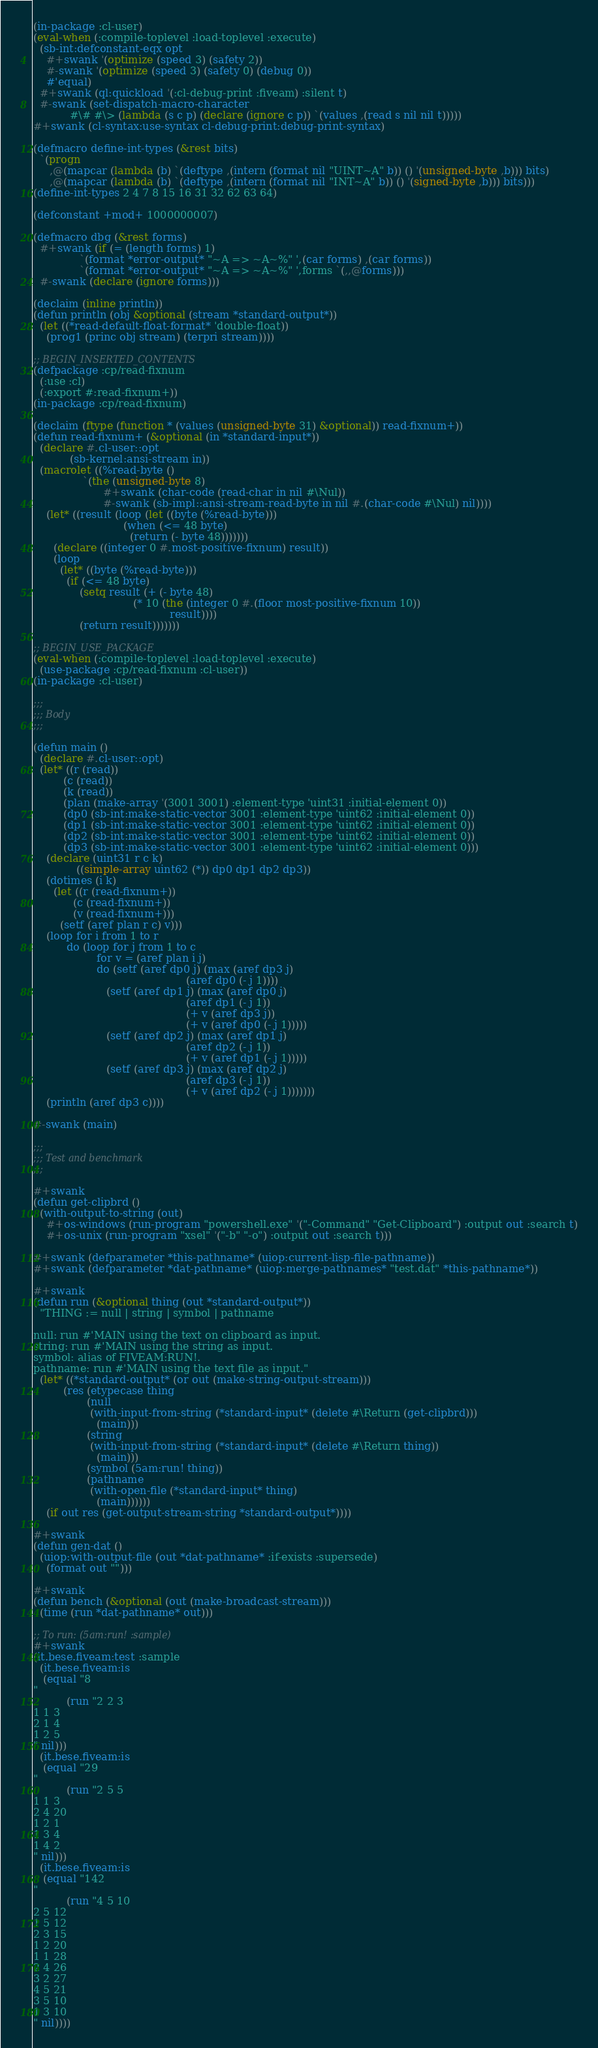<code> <loc_0><loc_0><loc_500><loc_500><_Lisp_>(in-package :cl-user)
(eval-when (:compile-toplevel :load-toplevel :execute)
  (sb-int:defconstant-eqx opt
    #+swank '(optimize (speed 3) (safety 2))
    #-swank '(optimize (speed 3) (safety 0) (debug 0))
    #'equal)
  #+swank (ql:quickload '(:cl-debug-print :fiveam) :silent t)
  #-swank (set-dispatch-macro-character
           #\# #\> (lambda (s c p) (declare (ignore c p)) `(values ,(read s nil nil t)))))
#+swank (cl-syntax:use-syntax cl-debug-print:debug-print-syntax)

(defmacro define-int-types (&rest bits)
  `(progn
     ,@(mapcar (lambda (b) `(deftype ,(intern (format nil "UINT~A" b)) () '(unsigned-byte ,b))) bits)
     ,@(mapcar (lambda (b) `(deftype ,(intern (format nil "INT~A" b)) () '(signed-byte ,b))) bits)))
(define-int-types 2 4 7 8 15 16 31 32 62 63 64)

(defconstant +mod+ 1000000007)

(defmacro dbg (&rest forms)
  #+swank (if (= (length forms) 1)
              `(format *error-output* "~A => ~A~%" ',(car forms) ,(car forms))
              `(format *error-output* "~A => ~A~%" ',forms `(,,@forms)))
  #-swank (declare (ignore forms)))

(declaim (inline println))
(defun println (obj &optional (stream *standard-output*))
  (let ((*read-default-float-format* 'double-float))
    (prog1 (princ obj stream) (terpri stream))))

;; BEGIN_INSERTED_CONTENTS
(defpackage :cp/read-fixnum
  (:use :cl)
  (:export #:read-fixnum+))
(in-package :cp/read-fixnum)

(declaim (ftype (function * (values (unsigned-byte 31) &optional)) read-fixnum+))
(defun read-fixnum+ (&optional (in *standard-input*))
  (declare #.cl-user::opt
           (sb-kernel:ansi-stream in))
  (macrolet ((%read-byte ()
               `(the (unsigned-byte 8)
                     #+swank (char-code (read-char in nil #\Nul))
                     #-swank (sb-impl::ansi-stream-read-byte in nil #.(char-code #\Nul) nil))))
    (let* ((result (loop (let ((byte (%read-byte)))
                           (when (<= 48 byte)
                             (return (- byte 48)))))))
      (declare ((integer 0 #.most-positive-fixnum) result))
      (loop
        (let* ((byte (%read-byte)))
          (if (<= 48 byte)
              (setq result (+ (- byte 48)
                              (* 10 (the (integer 0 #.(floor most-positive-fixnum 10))
                                         result))))
              (return result)))))))

;; BEGIN_USE_PACKAGE
(eval-when (:compile-toplevel :load-toplevel :execute)
  (use-package :cp/read-fixnum :cl-user))
(in-package :cl-user)

;;;
;;; Body
;;;

(defun main ()
  (declare #.cl-user::opt)
  (let* ((r (read))
         (c (read))
         (k (read))
         (plan (make-array '(3001 3001) :element-type 'uint31 :initial-element 0))
         (dp0 (sb-int:make-static-vector 3001 :element-type 'uint62 :initial-element 0))
         (dp1 (sb-int:make-static-vector 3001 :element-type 'uint62 :initial-element 0))
         (dp2 (sb-int:make-static-vector 3001 :element-type 'uint62 :initial-element 0))
         (dp3 (sb-int:make-static-vector 3001 :element-type 'uint62 :initial-element 0)))
    (declare (uint31 r c k)
             ((simple-array uint62 (*)) dp0 dp1 dp2 dp3))
    (dotimes (i k)
      (let ((r (read-fixnum+))
            (c (read-fixnum+))
            (v (read-fixnum+)))
        (setf (aref plan r c) v)))
    (loop for i from 1 to r
          do (loop for j from 1 to c
                   for v = (aref plan i j)
                   do (setf (aref dp0 j) (max (aref dp3 j)
                                              (aref dp0 (- j 1))))
                      (setf (aref dp1 j) (max (aref dp0 j)
                                              (aref dp1 (- j 1))
                                              (+ v (aref dp3 j))
                                              (+ v (aref dp0 (- j 1)))))
                      (setf (aref dp2 j) (max (aref dp1 j)
                                              (aref dp2 (- j 1))
                                              (+ v (aref dp1 (- j 1)))))
                      (setf (aref dp3 j) (max (aref dp2 j)
                                              (aref dp3 (- j 1))
                                              (+ v (aref dp2 (- j 1)))))))
    (println (aref dp3 c))))

#-swank (main)

;;;
;;; Test and benchmark
;;;

#+swank
(defun get-clipbrd ()
  (with-output-to-string (out)
    #+os-windows (run-program "powershell.exe" '("-Command" "Get-Clipboard") :output out :search t)
    #+os-unix (run-program "xsel" '("-b" "-o") :output out :search t)))

#+swank (defparameter *this-pathname* (uiop:current-lisp-file-pathname))
#+swank (defparameter *dat-pathname* (uiop:merge-pathnames* "test.dat" *this-pathname*))

#+swank
(defun run (&optional thing (out *standard-output*))
  "THING := null | string | symbol | pathname

null: run #'MAIN using the text on clipboard as input.
string: run #'MAIN using the string as input.
symbol: alias of FIVEAM:RUN!.
pathname: run #'MAIN using the text file as input."
  (let* ((*standard-output* (or out (make-string-output-stream)))
         (res (etypecase thing
                (null
                 (with-input-from-string (*standard-input* (delete #\Return (get-clipbrd)))
                   (main)))
                (string
                 (with-input-from-string (*standard-input* (delete #\Return thing))
                   (main)))
                (symbol (5am:run! thing))
                (pathname
                 (with-open-file (*standard-input* thing)
                   (main))))))
    (if out res (get-output-stream-string *standard-output*))))

#+swank
(defun gen-dat ()
  (uiop:with-output-file (out *dat-pathname* :if-exists :supersede)
    (format out "")))

#+swank
(defun bench (&optional (out (make-broadcast-stream)))
  (time (run *dat-pathname* out)))

;; To run: (5am:run! :sample)
#+swank
(it.bese.fiveam:test :sample
  (it.bese.fiveam:is
   (equal "8
"
          (run "2 2 3
1 1 3
2 1 4
1 2 5
" nil)))
  (it.bese.fiveam:is
   (equal "29
"
          (run "2 5 5
1 1 3
2 4 20
1 2 1
1 3 4
1 4 2
" nil)))
  (it.bese.fiveam:is
   (equal "142
"
          (run "4 5 10
2 5 12
1 5 12
2 3 15
1 2 20
1 1 28
2 4 26
3 2 27
4 5 21
3 5 10
1 3 10
" nil))))
</code> 